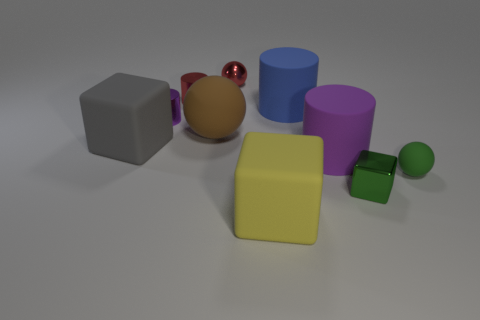Subtract all blocks. How many objects are left? 7 Add 9 small red spheres. How many small red spheres are left? 10 Add 4 large gray matte objects. How many large gray matte objects exist? 5 Subtract 0 yellow cylinders. How many objects are left? 10 Subtract all green spheres. Subtract all gray objects. How many objects are left? 8 